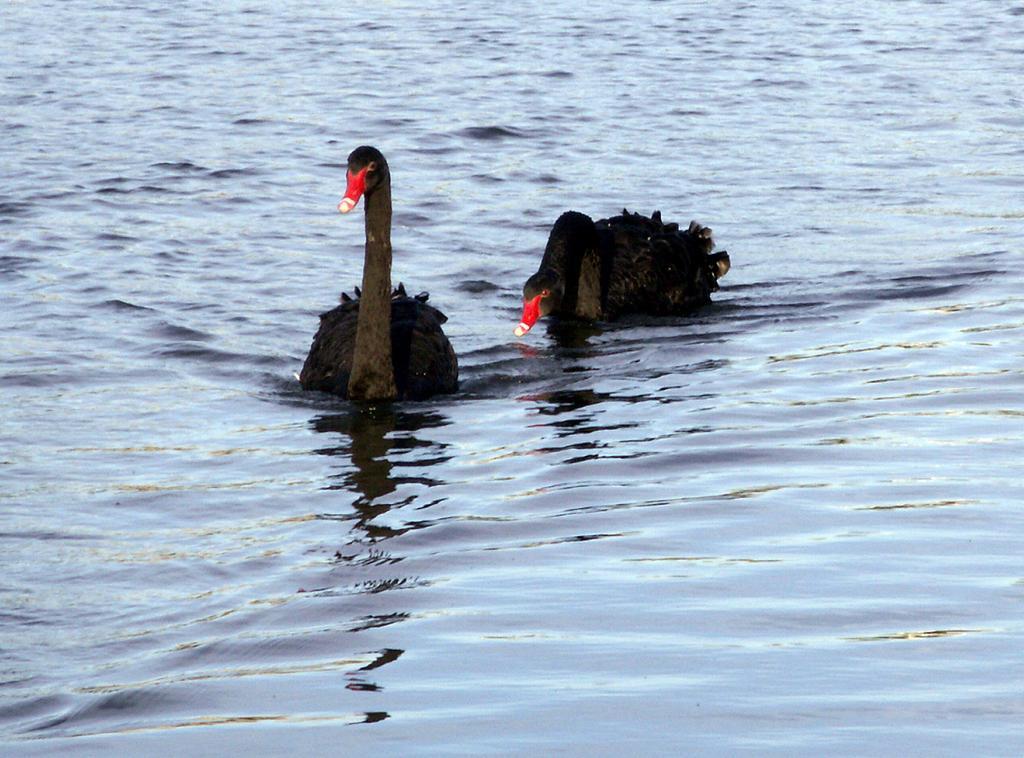Can you describe this image briefly? This picture contains two black swans swimming in the water. This water might be in the pond. This swan has a red color beak. 